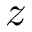Convert formula to latex. <formula><loc_0><loc_0><loc_500><loc_500>z</formula> 